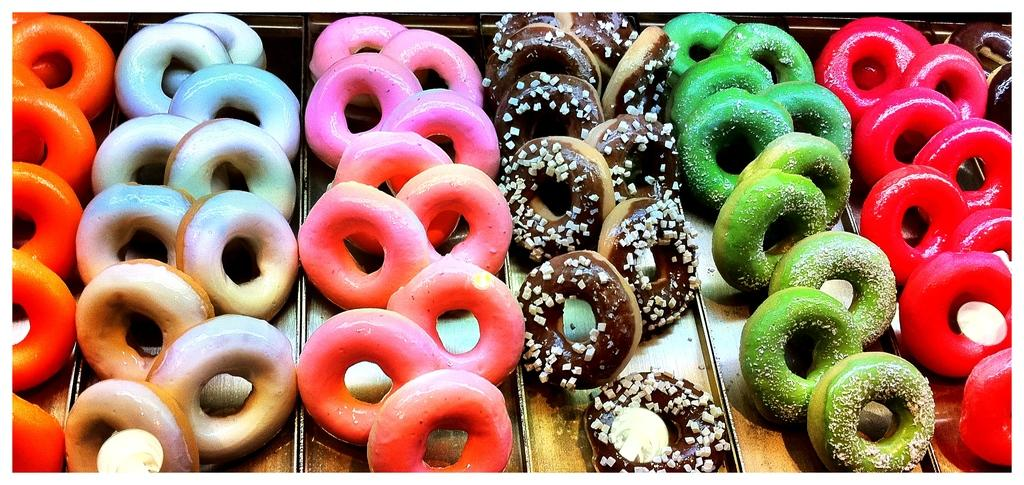What type of food is present in the image? There are doughnuts in the image. How many different colors can be seen among the doughnuts? The doughnuts come in different colors. How are the doughnuts arranged in the image? The doughnuts are placed on separate plates. What degree is required to use the hammer in the image? There is no hammer present in the image, so the question is not applicable. 